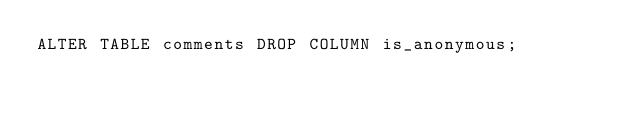<code> <loc_0><loc_0><loc_500><loc_500><_SQL_>ALTER TABLE comments DROP COLUMN is_anonymous;
</code> 